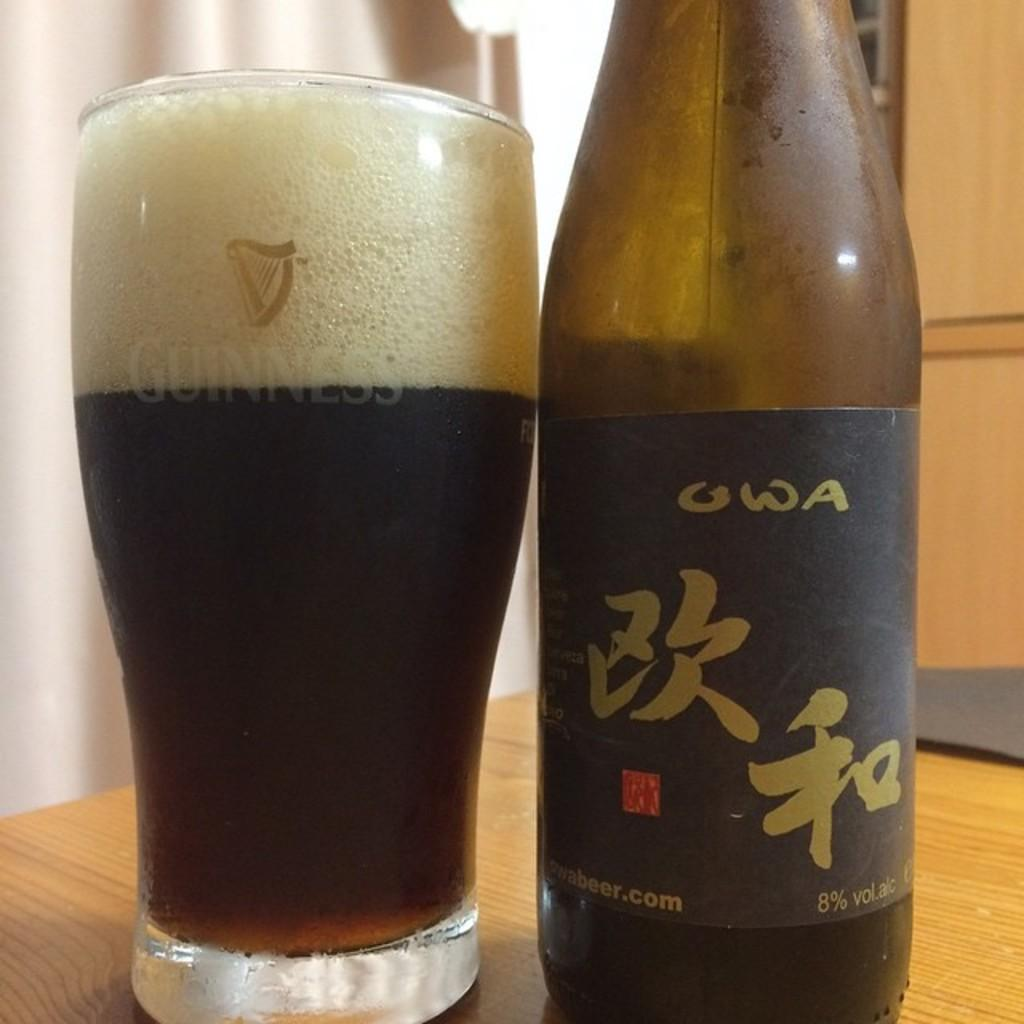<image>
Present a compact description of the photo's key features. bottle of owa beer that is 8% alcohol next to a glass of it 